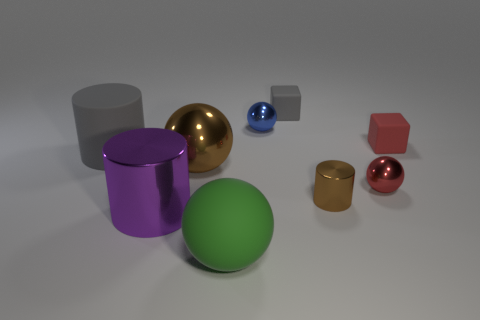What size is the thing that is the same color as the large matte cylinder?
Provide a succinct answer. Small. What size is the purple metal object that is the same shape as the large gray thing?
Provide a succinct answer. Large. Is there anything else that has the same size as the purple object?
Provide a succinct answer. Yes. What is the material of the big purple object that is in front of the gray matte block behind the tiny shiny cylinder that is right of the green rubber ball?
Make the answer very short. Metal. Are there more shiny things that are behind the red shiny ball than brown shiny balls that are in front of the large green ball?
Your answer should be compact. Yes. Do the blue metal ball and the gray matte cylinder have the same size?
Your answer should be compact. No. What is the color of the small metal object that is the same shape as the large purple thing?
Offer a terse response. Brown. How many other rubber cylinders have the same color as the tiny cylinder?
Give a very brief answer. 0. Is the number of metal things in front of the green matte ball greater than the number of big metallic objects?
Make the answer very short. No. There is a matte object in front of the brown metallic thing that is to the right of the tiny gray cube; what color is it?
Offer a terse response. Green. 